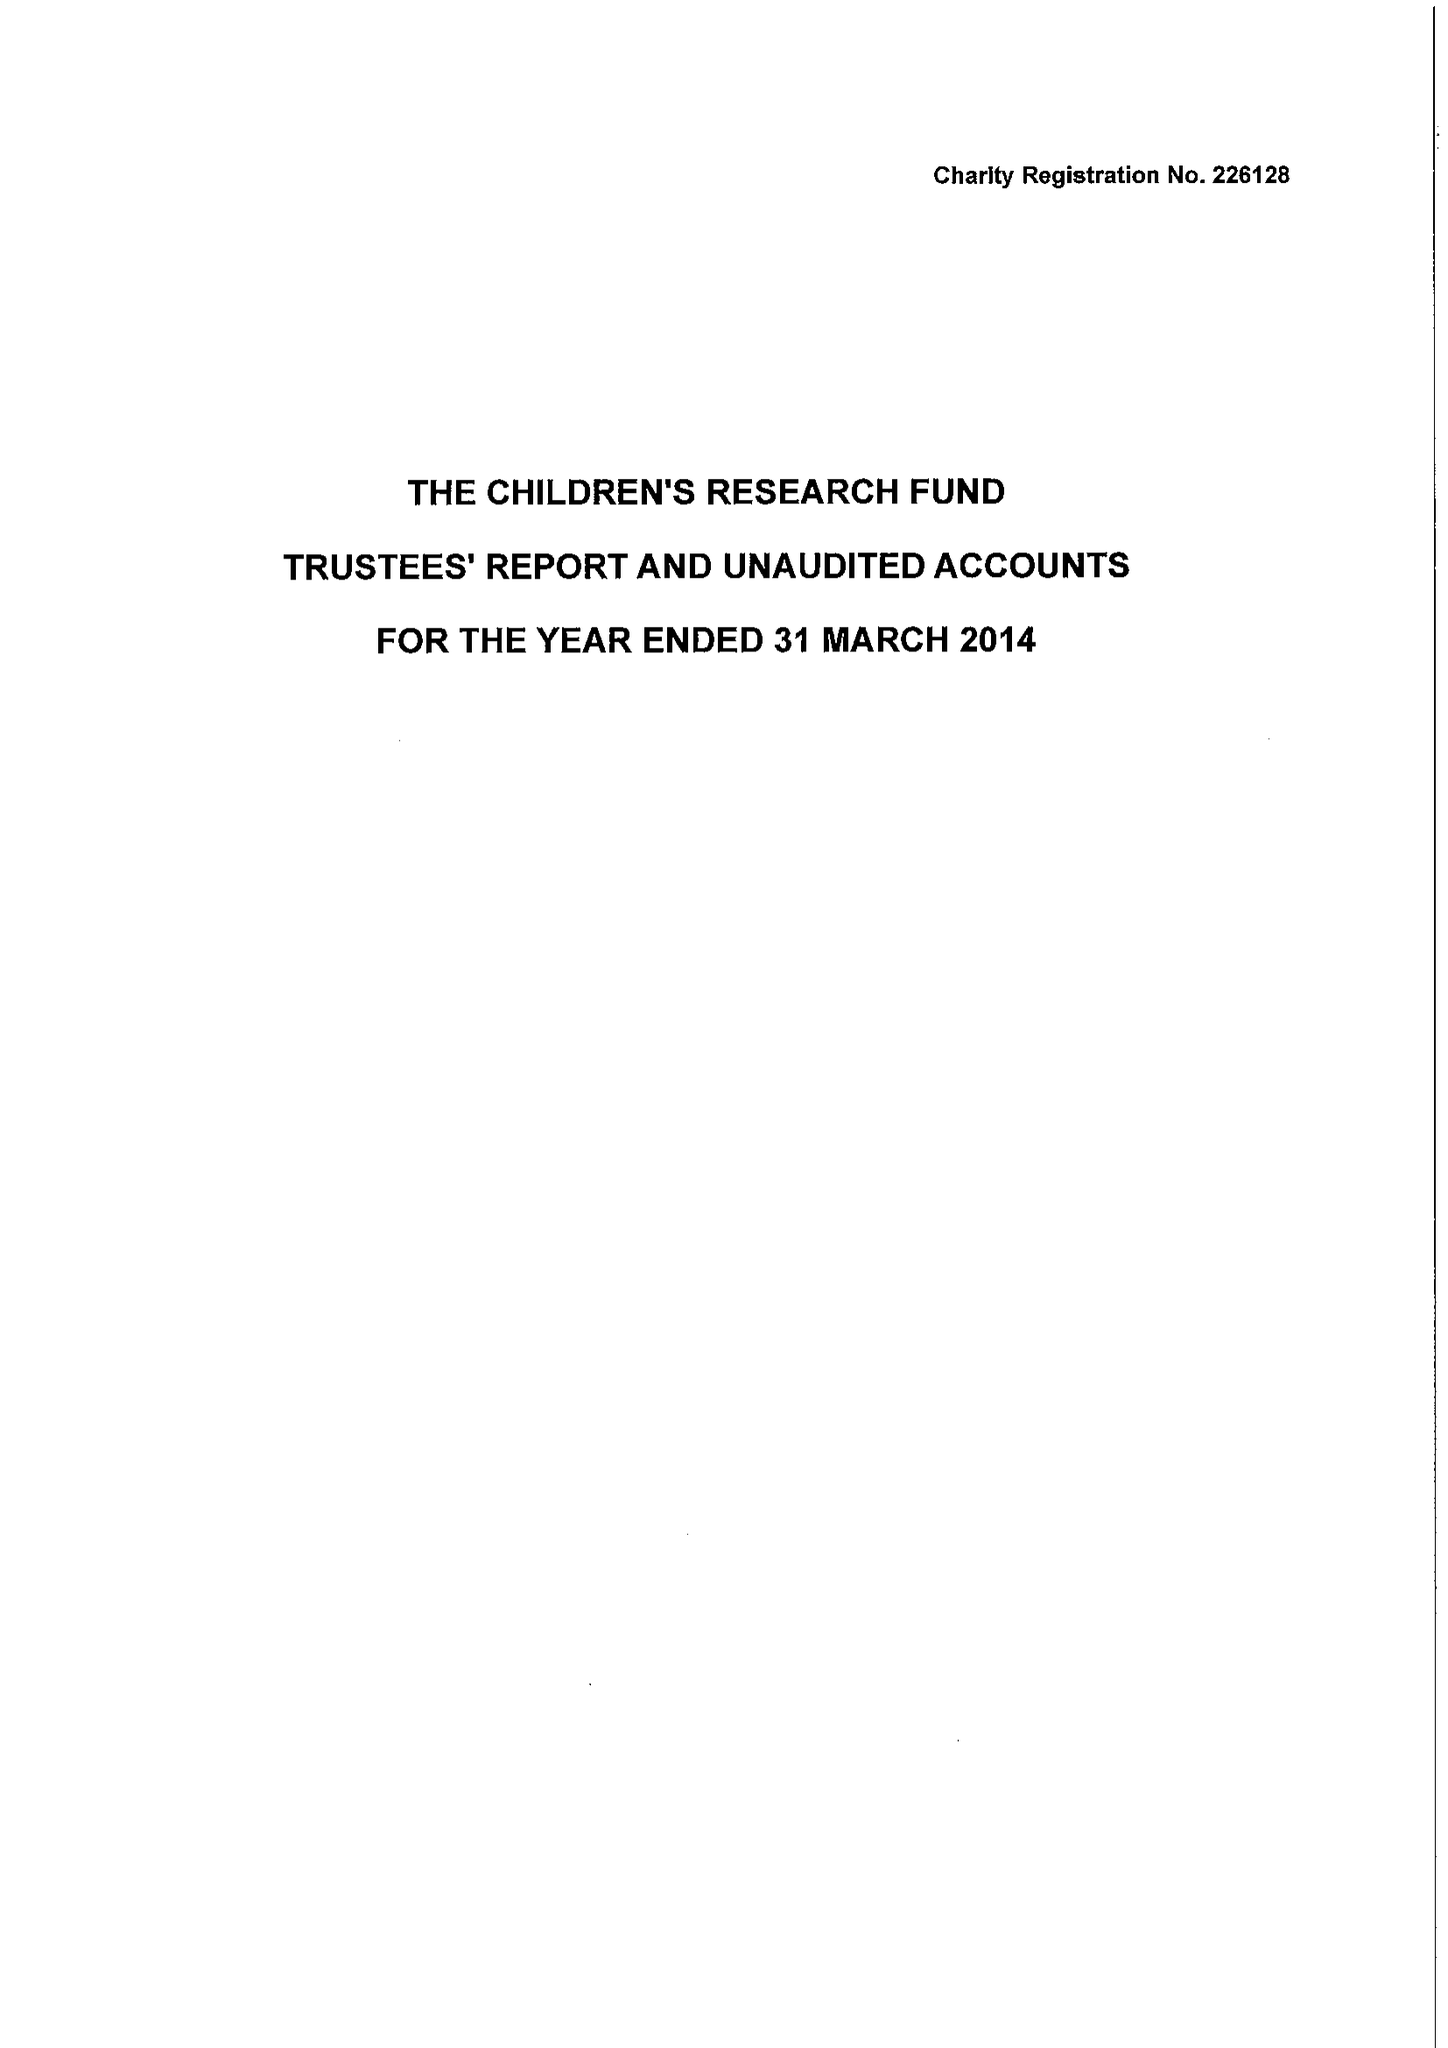What is the value for the income_annually_in_british_pounds?
Answer the question using a single word or phrase. 28516.00 